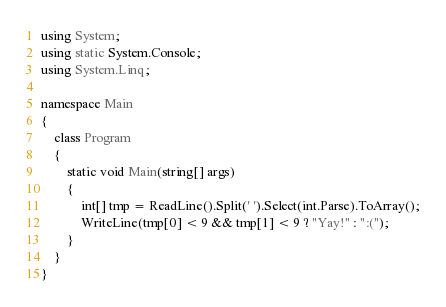Convert code to text. <code><loc_0><loc_0><loc_500><loc_500><_C#_>using System;
using static System.Console;
using System.Linq;

namespace Main
{
    class Program
    {
        static void Main(string[] args)
        {
            int[] tmp = ReadLine().Split(' ').Select(int.Parse).ToArray();
            WriteLine(tmp[0] < 9 && tmp[1] < 9 ? "Yay!" : ":(");
        }
    }
}</code> 